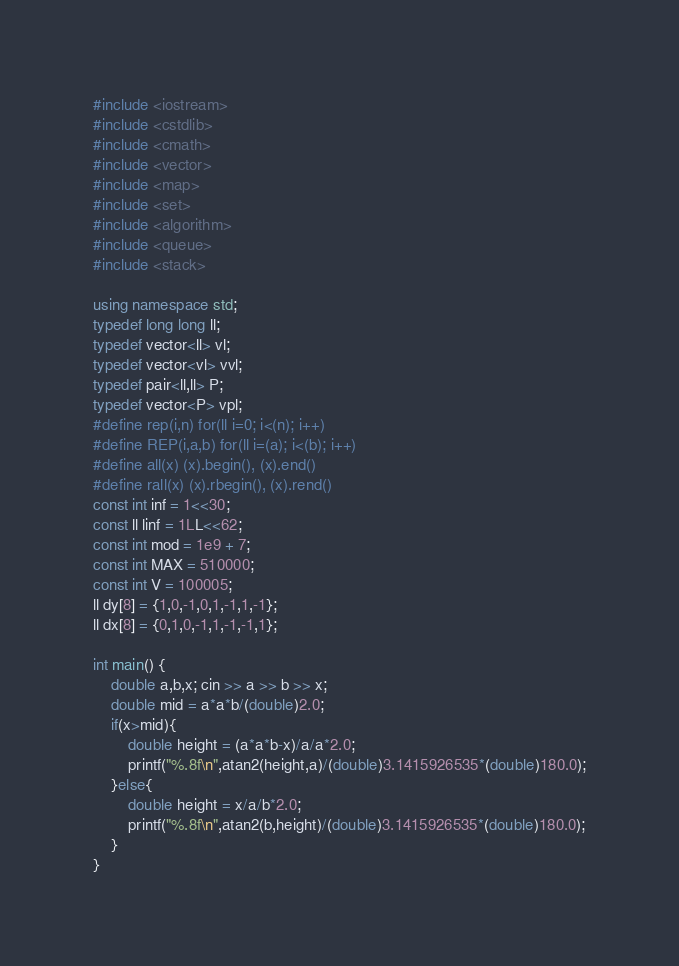Convert code to text. <code><loc_0><loc_0><loc_500><loc_500><_C++_>#include <iostream>
#include <cstdlib>
#include <cmath>
#include <vector>
#include <map>
#include <set>
#include <algorithm>
#include <queue>
#include <stack>

using namespace std;
typedef long long ll;
typedef vector<ll> vl;
typedef vector<vl> vvl;
typedef pair<ll,ll> P;
typedef vector<P> vpl;
#define rep(i,n) for(ll i=0; i<(n); i++)
#define REP(i,a,b) for(ll i=(a); i<(b); i++)
#define all(x) (x).begin(), (x).end()
#define rall(x) (x).rbegin(), (x).rend()
const int inf = 1<<30;
const ll linf = 1LL<<62;
const int mod = 1e9 + 7;
const int MAX = 510000;
const int V = 100005;
ll dy[8] = {1,0,-1,0,1,-1,1,-1};
ll dx[8] = {0,1,0,-1,1,-1,-1,1};

int main() {
    double a,b,x; cin >> a >> b >> x;
    double mid = a*a*b/(double)2.0;
    if(x>mid){
        double height = (a*a*b-x)/a/a*2.0;
        printf("%.8f\n",atan2(height,a)/(double)3.1415926535*(double)180.0);
    }else{
        double height = x/a/b*2.0;
        printf("%.8f\n",atan2(b,height)/(double)3.1415926535*(double)180.0);
    }
}
</code> 